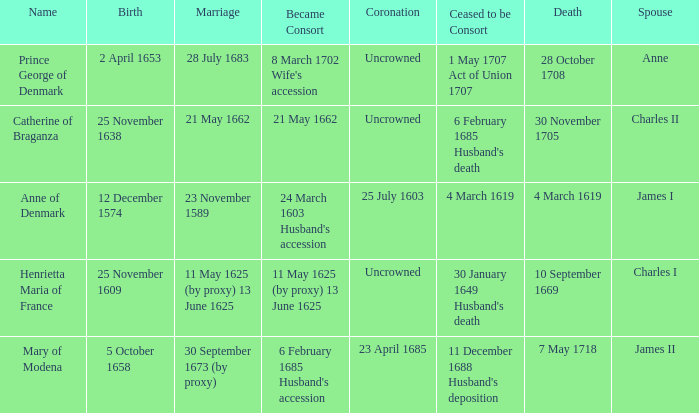Can you give me this table as a dict? {'header': ['Name', 'Birth', 'Marriage', 'Became Consort', 'Coronation', 'Ceased to be Consort', 'Death', 'Spouse'], 'rows': [['Prince George of Denmark', '2 April 1653', '28 July 1683', "8 March 1702 Wife's accession", 'Uncrowned', '1 May 1707 Act of Union 1707', '28 October 1708', 'Anne'], ['Catherine of Braganza', '25 November 1638', '21 May 1662', '21 May 1662', 'Uncrowned', "6 February 1685 Husband's death", '30 November 1705', 'Charles II'], ['Anne of Denmark', '12 December 1574', '23 November 1589', "24 March 1603 Husband's accession", '25 July 1603', '4 March 1619', '4 March 1619', 'James I'], ['Henrietta Maria of France', '25 November 1609', '11 May 1625 (by proxy) 13 June 1625', '11 May 1625 (by proxy) 13 June 1625', 'Uncrowned', "30 January 1649 Husband's death", '10 September 1669', 'Charles I'], ['Mary of Modena', '5 October 1658', '30 September 1673 (by proxy)', "6 February 1685 Husband's accession", '23 April 1685', "11 December 1688 Husband's deposition", '7 May 1718', 'James II']]} When was the date of death for the person married to Charles II? 30 November 1705. 